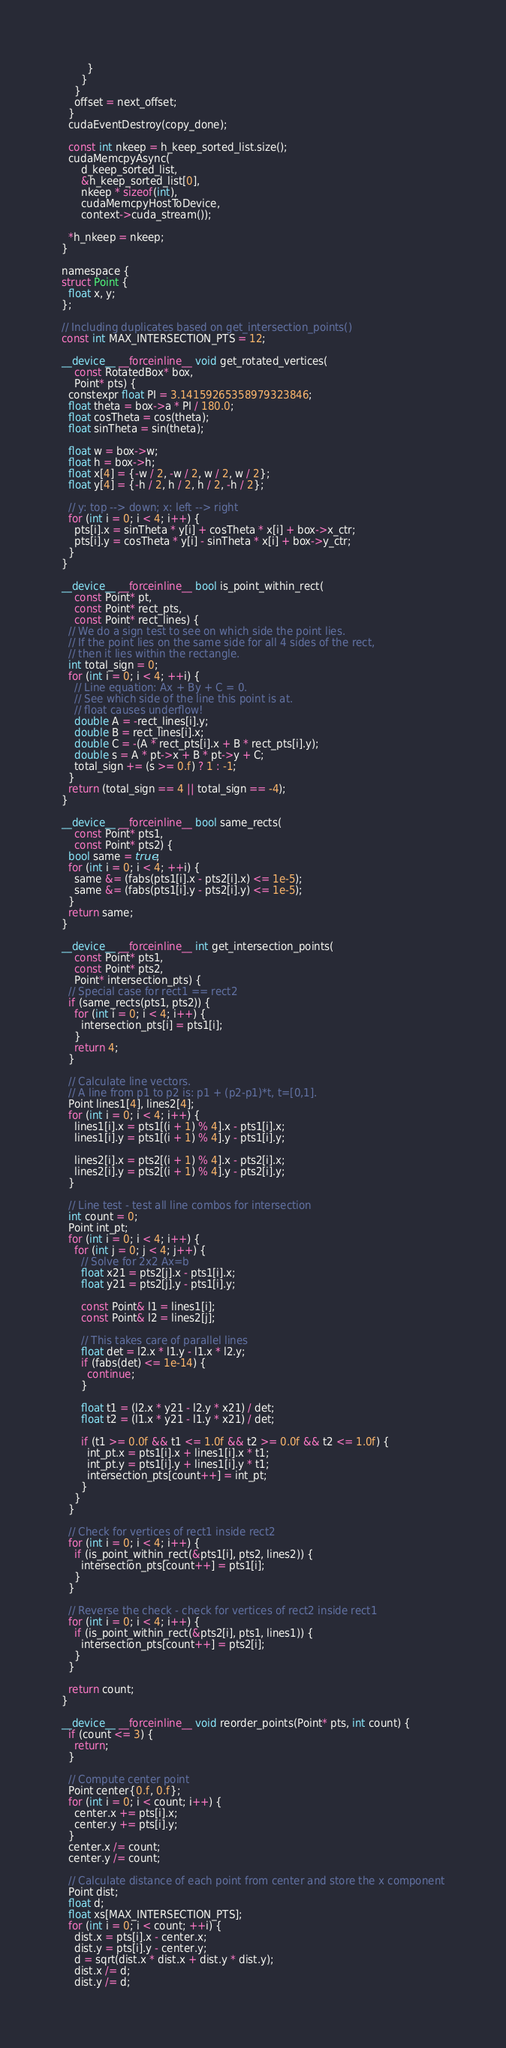Convert code to text. <code><loc_0><loc_0><loc_500><loc_500><_Cuda_>        }
      }
    }
    offset = next_offset;
  }
  cudaEventDestroy(copy_done);

  const int nkeep = h_keep_sorted_list.size();
  cudaMemcpyAsync(
      d_keep_sorted_list,
      &h_keep_sorted_list[0],
      nkeep * sizeof(int),
      cudaMemcpyHostToDevice,
      context->cuda_stream());

  *h_nkeep = nkeep;
}

namespace {
struct Point {
  float x, y;
};

// Including duplicates based on get_intersection_points()
const int MAX_INTERSECTION_PTS = 12;

__device__ __forceinline__ void get_rotated_vertices(
    const RotatedBox* box,
    Point* pts) {
  constexpr float PI = 3.14159265358979323846;
  float theta = box->a * PI / 180.0;
  float cosTheta = cos(theta);
  float sinTheta = sin(theta);

  float w = box->w;
  float h = box->h;
  float x[4] = {-w / 2, -w / 2, w / 2, w / 2};
  float y[4] = {-h / 2, h / 2, h / 2, -h / 2};

  // y: top --> down; x: left --> right
  for (int i = 0; i < 4; i++) {
    pts[i].x = sinTheta * y[i] + cosTheta * x[i] + box->x_ctr;
    pts[i].y = cosTheta * y[i] - sinTheta * x[i] + box->y_ctr;
  }
}

__device__ __forceinline__ bool is_point_within_rect(
    const Point* pt,
    const Point* rect_pts,
    const Point* rect_lines) {
  // We do a sign test to see on which side the point lies.
  // If the point lies on the same side for all 4 sides of the rect,
  // then it lies within the rectangle.
  int total_sign = 0;
  for (int i = 0; i < 4; ++i) {
    // Line equation: Ax + By + C = 0.
    // See which side of the line this point is at.
    // float causes underflow!
    double A = -rect_lines[i].y;
    double B = rect_lines[i].x;
    double C = -(A * rect_pts[i].x + B * rect_pts[i].y);
    double s = A * pt->x + B * pt->y + C;
    total_sign += (s >= 0.f) ? 1 : -1;
  }
  return (total_sign == 4 || total_sign == -4);
}

__device__ __forceinline__ bool same_rects(
    const Point* pts1,
    const Point* pts2) {
  bool same = true;
  for (int i = 0; i < 4; ++i) {
    same &= (fabs(pts1[i].x - pts2[i].x) <= 1e-5);
    same &= (fabs(pts1[i].y - pts2[i].y) <= 1e-5);
  }
  return same;
}

__device__ __forceinline__ int get_intersection_points(
    const Point* pts1,
    const Point* pts2,
    Point* intersection_pts) {
  // Special case for rect1 == rect2
  if (same_rects(pts1, pts2)) {
    for (int i = 0; i < 4; i++) {
      intersection_pts[i] = pts1[i];
    }
    return 4;
  }

  // Calculate line vectors.
  // A line from p1 to p2 is: p1 + (p2-p1)*t, t=[0,1].
  Point lines1[4], lines2[4];
  for (int i = 0; i < 4; i++) {
    lines1[i].x = pts1[(i + 1) % 4].x - pts1[i].x;
    lines1[i].y = pts1[(i + 1) % 4].y - pts1[i].y;

    lines2[i].x = pts2[(i + 1) % 4].x - pts2[i].x;
    lines2[i].y = pts2[(i + 1) % 4].y - pts2[i].y;
  }

  // Line test - test all line combos for intersection
  int count = 0;
  Point int_pt;
  for (int i = 0; i < 4; i++) {
    for (int j = 0; j < 4; j++) {
      // Solve for 2x2 Ax=b
      float x21 = pts2[j].x - pts1[i].x;
      float y21 = pts2[j].y - pts1[i].y;

      const Point& l1 = lines1[i];
      const Point& l2 = lines2[j];

      // This takes care of parallel lines
      float det = l2.x * l1.y - l1.x * l2.y;
      if (fabs(det) <= 1e-14) {
        continue;
      }

      float t1 = (l2.x * y21 - l2.y * x21) / det;
      float t2 = (l1.x * y21 - l1.y * x21) / det;

      if (t1 >= 0.0f && t1 <= 1.0f && t2 >= 0.0f && t2 <= 1.0f) {
        int_pt.x = pts1[i].x + lines1[i].x * t1;
        int_pt.y = pts1[i].y + lines1[i].y * t1;
        intersection_pts[count++] = int_pt;
      }
    }
  }

  // Check for vertices of rect1 inside rect2
  for (int i = 0; i < 4; i++) {
    if (is_point_within_rect(&pts1[i], pts2, lines2)) {
      intersection_pts[count++] = pts1[i];
    }
  }

  // Reverse the check - check for vertices of rect2 inside rect1
  for (int i = 0; i < 4; i++) {
    if (is_point_within_rect(&pts2[i], pts1, lines1)) {
      intersection_pts[count++] = pts2[i];
    }
  }

  return count;
}

__device__ __forceinline__ void reorder_points(Point* pts, int count) {
  if (count <= 3) {
    return;
  }

  // Compute center point
  Point center{0.f, 0.f};
  for (int i = 0; i < count; i++) {
    center.x += pts[i].x;
    center.y += pts[i].y;
  }
  center.x /= count;
  center.y /= count;

  // Calculate distance of each point from center and store the x component
  Point dist;
  float d;
  float xs[MAX_INTERSECTION_PTS];
  for (int i = 0; i < count; ++i) {
    dist.x = pts[i].x - center.x;
    dist.y = pts[i].y - center.y;
    d = sqrt(dist.x * dist.x + dist.y * dist.y);
    dist.x /= d;
    dist.y /= d;</code> 